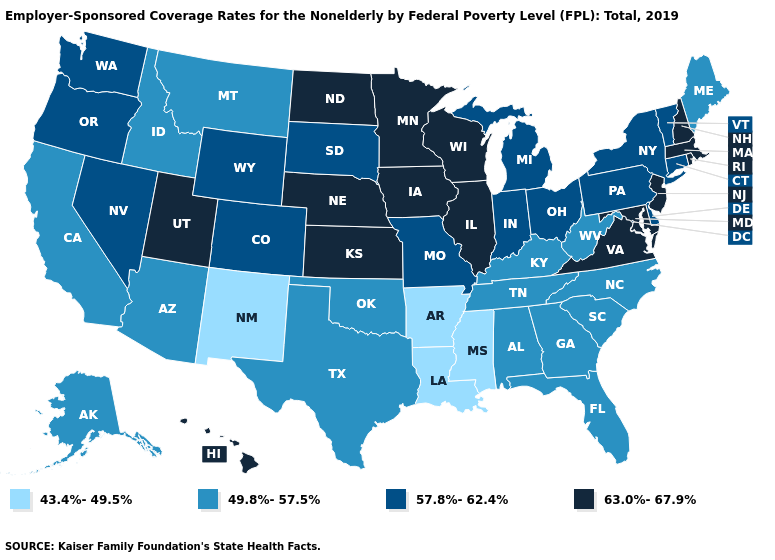Among the states that border Nebraska , which have the highest value?
Quick response, please. Iowa, Kansas. Which states have the highest value in the USA?
Concise answer only. Hawaii, Illinois, Iowa, Kansas, Maryland, Massachusetts, Minnesota, Nebraska, New Hampshire, New Jersey, North Dakota, Rhode Island, Utah, Virginia, Wisconsin. Does Oklahoma have a lower value than Colorado?
Be succinct. Yes. Does Pennsylvania have a lower value than Wyoming?
Write a very short answer. No. What is the value of Wyoming?
Keep it brief. 57.8%-62.4%. Does Ohio have a higher value than New York?
Concise answer only. No. Name the states that have a value in the range 57.8%-62.4%?
Be succinct. Colorado, Connecticut, Delaware, Indiana, Michigan, Missouri, Nevada, New York, Ohio, Oregon, Pennsylvania, South Dakota, Vermont, Washington, Wyoming. Does the first symbol in the legend represent the smallest category?
Keep it brief. Yes. Does Maryland have a higher value than West Virginia?
Be succinct. Yes. Name the states that have a value in the range 63.0%-67.9%?
Be succinct. Hawaii, Illinois, Iowa, Kansas, Maryland, Massachusetts, Minnesota, Nebraska, New Hampshire, New Jersey, North Dakota, Rhode Island, Utah, Virginia, Wisconsin. Does the first symbol in the legend represent the smallest category?
Quick response, please. Yes. Name the states that have a value in the range 63.0%-67.9%?
Write a very short answer. Hawaii, Illinois, Iowa, Kansas, Maryland, Massachusetts, Minnesota, Nebraska, New Hampshire, New Jersey, North Dakota, Rhode Island, Utah, Virginia, Wisconsin. What is the value of North Dakota?
Answer briefly. 63.0%-67.9%. Does Iowa have the highest value in the MidWest?
Give a very brief answer. Yes. Does the map have missing data?
Be succinct. No. 